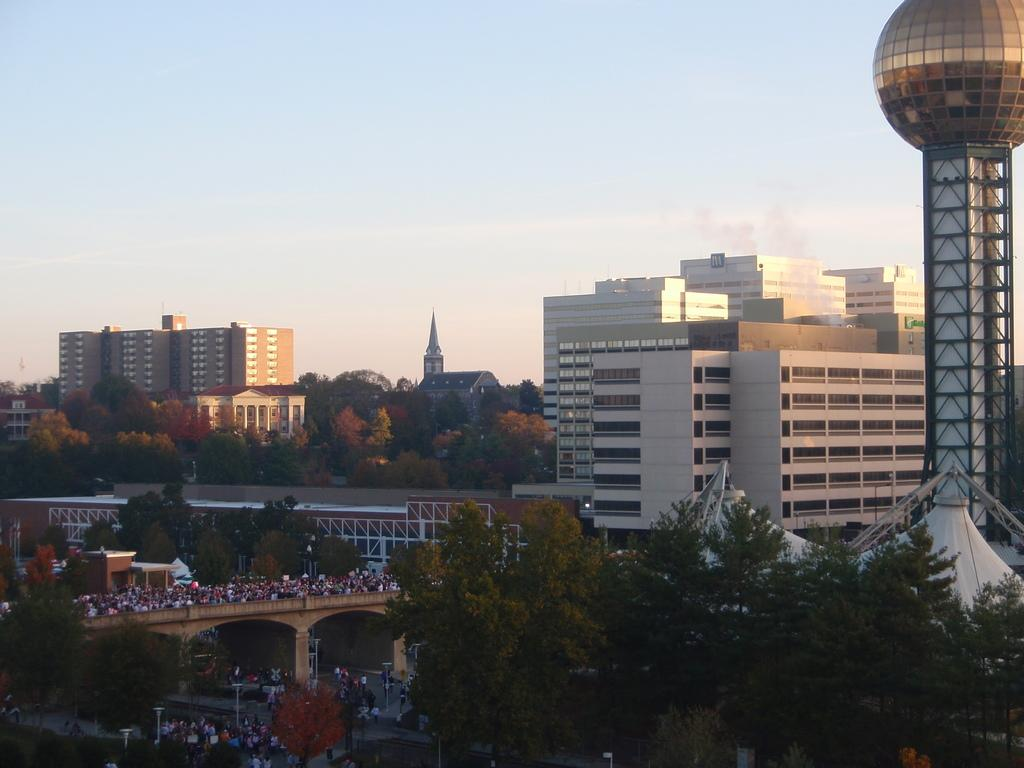What type of structures can be seen in the image? There are buildings in the image. What other natural elements are present in the image? There are trees in the image. What type of man-made infrastructure is visible in the image? There are roads in the image. Are there any living beings present in the image? Yes, there are people in the image. Can you describe any other objects in the image? There are other objects in the image, but their specific details are not mentioned in the provided facts. What can be seen in the background of the image? The sky is visible in the background of the image, and there is a tower in the background as well. Reasoning: Let's think step by step by step in order to produce the conversation. We start by identifying the main subjects and objects in the image based on the provided facts. We then formulate questions that focus on the location and characteristics of these subjects and objects, ensuring that each question can be answered definitively with the information given. We avoid yes/no questions and ensure that the language is simple and clear. Absurd Question/Answer: Can you see a kitten pulling a smoke-filled wagon in the image? No, there is no kitten or smoke-filled wagon present in the image. Are there any kittens pulling a smoke-filled wagon in the image? No, there are no kittens or smoke-filled wagons present in the image. 